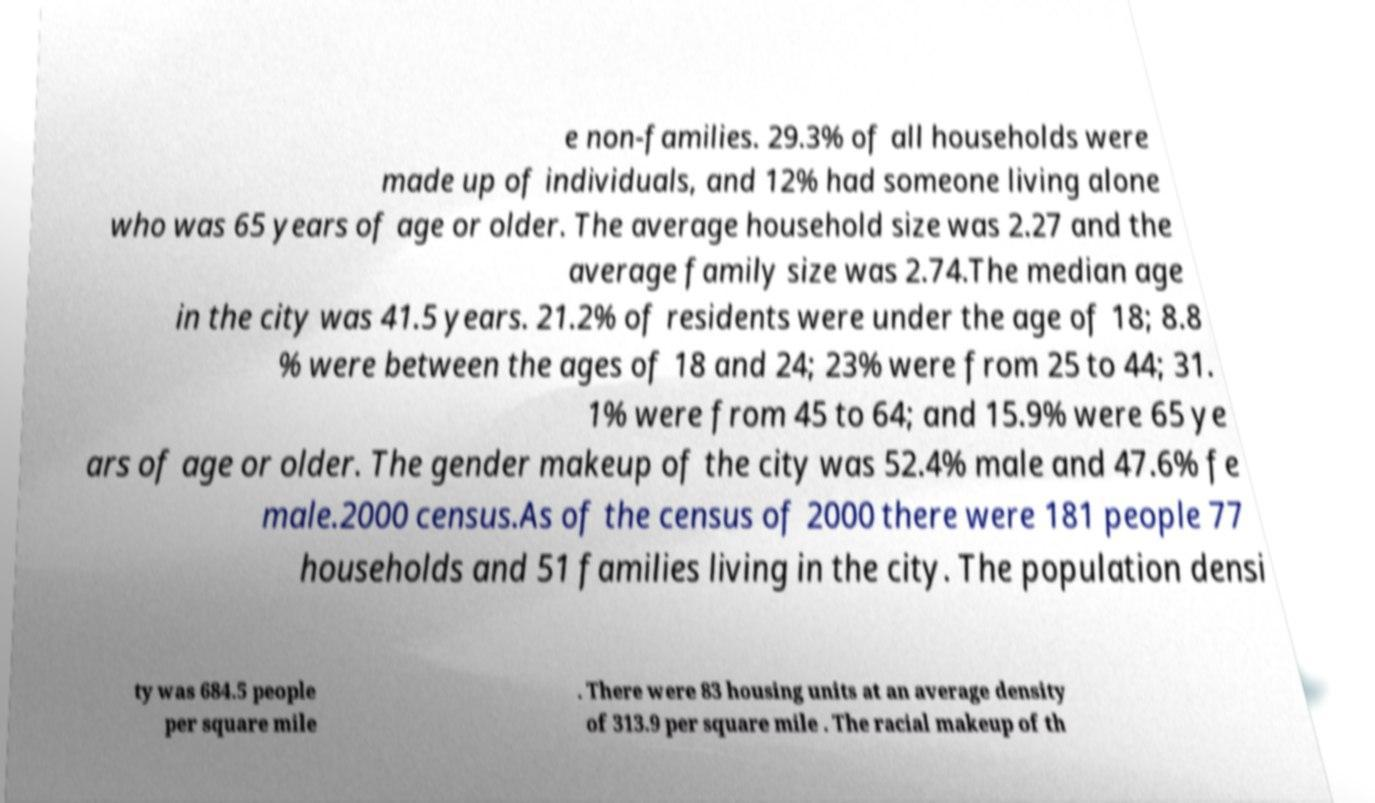Please read and relay the text visible in this image. What does it say? e non-families. 29.3% of all households were made up of individuals, and 12% had someone living alone who was 65 years of age or older. The average household size was 2.27 and the average family size was 2.74.The median age in the city was 41.5 years. 21.2% of residents were under the age of 18; 8.8 % were between the ages of 18 and 24; 23% were from 25 to 44; 31. 1% were from 45 to 64; and 15.9% were 65 ye ars of age or older. The gender makeup of the city was 52.4% male and 47.6% fe male.2000 census.As of the census of 2000 there were 181 people 77 households and 51 families living in the city. The population densi ty was 684.5 people per square mile . There were 83 housing units at an average density of 313.9 per square mile . The racial makeup of th 